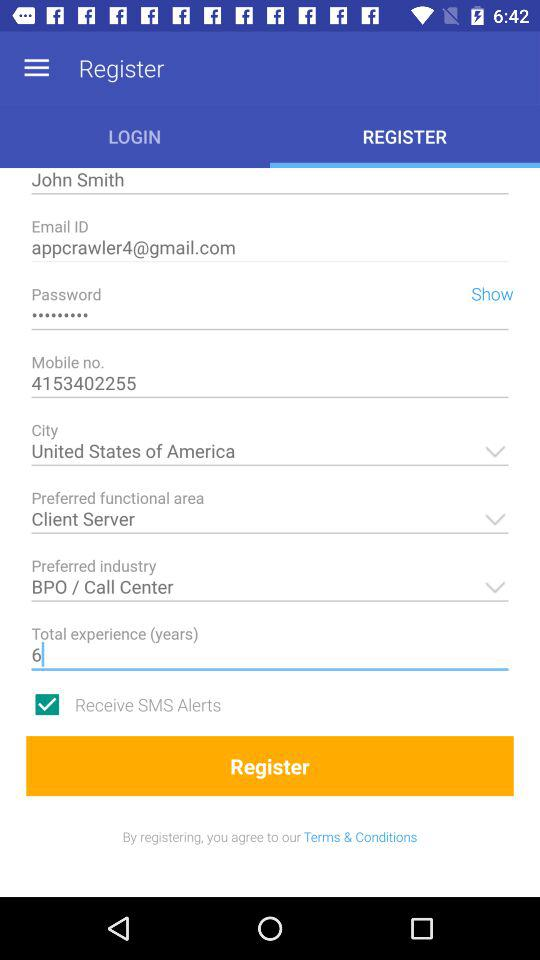What is the total number of years of experience? The total number of years of experience is 6. 